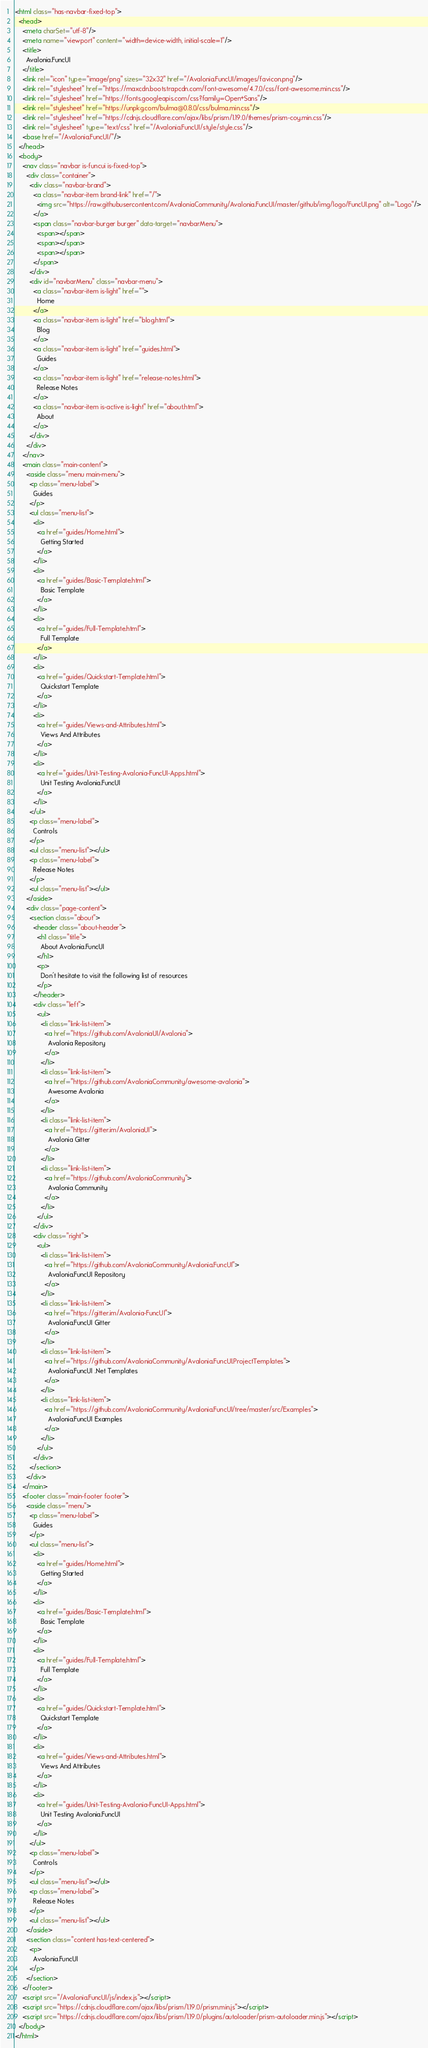<code> <loc_0><loc_0><loc_500><loc_500><_HTML_><html class="has-navbar-fixed-top">
  <head>
    <meta charSet="utf-8"/>
    <meta name="viewport" content="width=device-width, initial-scale=1"/>
    <title>
      Avalonia.FuncUI
    </title>
    <link rel="icon" type="image/png" sizes="32x32" href="/Avalonia.FuncUI/images/favicon.png"/>
    <link rel="stylesheet" href="https://maxcdn.bootstrapcdn.com/font-awesome/4.7.0/css/font-awesome.min.css"/>
    <link rel="stylesheet" href="https://fonts.googleapis.com/css?family=Open+Sans"/>
    <link rel="stylesheet" href="https://unpkg.com/bulma@0.8.0/css/bulma.min.css"/>
    <link rel="stylesheet" href="https://cdnjs.cloudflare.com/ajax/libs/prism/1.19.0/themes/prism-coy.min.css"/>
    <link rel="stylesheet" type="text/css" href="/Avalonia.FuncUI/style/style.css"/>
    <base href="/Avalonia.FuncUI/"/>
  </head>
  <body>
    <nav class="navbar is-funcui is-fixed-top">
      <div class="container">
        <div class="navbar-brand">
          <a class="navbar-item brand-link" href="/">
            <img src="https://raw.githubusercontent.com/AvaloniaCommunity/Avalonia.FuncUI/master/github/img/logo/FuncUI.png" alt="Logo"/>
          </a>
          <span class="navbar-burger burger" data-target="navbarMenu">
            <span></span>
            <span></span>
            <span></span>
          </span>
        </div>
        <div id="navbarMenu" class="navbar-menu">
          <a class="navbar-item is-light" href="">
            Home
          </a>
          <a class="navbar-item is-light" href="blog.html">
            Blog
          </a>
          <a class="navbar-item is-light" href="guides.html">
            Guides
          </a>
          <a class="navbar-item is-light" href="release-notes.html">
            Release Notes
          </a>
          <a class="navbar-item is-active is-light" href="about.html">
            About
          </a>
        </div>
      </div>
    </nav>
    <main class="main-content">
      <aside class="menu main-menu">
        <p class="menu-label">
          Guides
        </p>
        <ul class="menu-list">
          <li>
            <a href="guides/Home.html">
              Getting Started
            </a>
          </li>
          <li>
            <a href="guides/Basic-Template.html">
              Basic Template
            </a>
          </li>
          <li>
            <a href="guides/Full-Template.html">
              Full Template
            </a>
          </li>
          <li>
            <a href="guides/Quickstart-Template.html">
              Quickstart Template
            </a>
          </li>
          <li>
            <a href="guides/Views-and-Attributes.html">
              Views And Attributes
            </a>
          </li>
          <li>
            <a href="guides/Unit-Testing-Avalonia-FuncUI-Apps.html">
              Unit Testing Avalonia.FuncUI
            </a>
          </li>
        </ul>
        <p class="menu-label">
          Controls
        </p>
        <ul class="menu-list"></ul>
        <p class="menu-label">
          Release Notes
        </p>
        <ul class="menu-list"></ul>
      </aside>
      <div class="page-content">
        <section class="about">
          <header class="about-header">
            <h1 class="title">
              About Avalonia.FuncUI
            </h1>
            <p>
              Don't hesitate to visit the following list of resources
            </p>
          </header>
          <div class="left">
            <ul>
              <li class="link-list-item">
                <a href="https://github.com/AvaloniaUI/Avalonia">
                  Avalonia Repository
                </a>
              </li>
              <li class="link-list-item">
                <a href="https://github.com/AvaloniaCommunity/awesome-avalonia">
                  Awesome Avalonia
                </a>
              </li>
              <li class="link-list-item">
                <a href="https://gitter.im/AvaloniaUI">
                  Avalonia Gitter
                </a>
              </li>
              <li class="link-list-item">
                <a href="https://github.com/AvaloniaCommunity">
                  Avalonia Community
                </a>
              </li>
            </ul>
          </div>
          <div class="right">
            <ul>
              <li class="link-list-item">
                <a href="https://github.com/AvaloniaCommunity/Avalonia.FuncUI">
                  Avalonia.FuncUI Repository
                </a>
              </li>
              <li class="link-list-item">
                <a href="https://gitter.im/Avalonia-FuncUI">
                  Avalonia.FuncUI Gitter
                </a>
              </li>
              <li class="link-list-item">
                <a href="https://github.com/AvaloniaCommunity/Avalonia.FuncUI.ProjectTemplates">
                  Avalonia.FuncUI .Net Templates
                </a>
              </li>
              <li class="link-list-item">
                <a href="https://github.com/AvaloniaCommunity/Avalonia.FuncUI/tree/master/src/Examples">
                  Avalonia.FuncUI Examples
                </a>
              </li>
            </ul>
          </div>
        </section>
      </div>
    </main>
    <footer class="main-footer footer">
      <aside class="menu">
        <p class="menu-label">
          Guides
        </p>
        <ul class="menu-list">
          <li>
            <a href="guides/Home.html">
              Getting Started
            </a>
          </li>
          <li>
            <a href="guides/Basic-Template.html">
              Basic Template
            </a>
          </li>
          <li>
            <a href="guides/Full-Template.html">
              Full Template
            </a>
          </li>
          <li>
            <a href="guides/Quickstart-Template.html">
              Quickstart Template
            </a>
          </li>
          <li>
            <a href="guides/Views-and-Attributes.html">
              Views And Attributes
            </a>
          </li>
          <li>
            <a href="guides/Unit-Testing-Avalonia-FuncUI-Apps.html">
              Unit Testing Avalonia.FuncUI
            </a>
          </li>
        </ul>
        <p class="menu-label">
          Controls
        </p>
        <ul class="menu-list"></ul>
        <p class="menu-label">
          Release Notes
        </p>
        <ul class="menu-list"></ul>
      </aside>
      <section class="content has-text-centered">
        <p>
          Avalonia.FuncUI
        </p>
      </section>
    </footer>
    <script src="/Avalonia.FuncUI/js/index.js"></script>
    <script src="https://cdnjs.cloudflare.com/ajax/libs/prism/1.19.0/prism.min.js"></script>
    <script src="https://cdnjs.cloudflare.com/ajax/libs/prism/1.19.0/plugins/autoloader/prism-autoloader.min.js"></script>
  </body>
</html></code> 